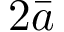Convert formula to latex. <formula><loc_0><loc_0><loc_500><loc_500>2 \bar { a }</formula> 